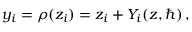Convert formula to latex. <formula><loc_0><loc_0><loc_500><loc_500>y _ { i } = \rho ( z _ { i } ) = z _ { i } + Y _ { i } ( z , \hbar { ) } \, ,</formula> 